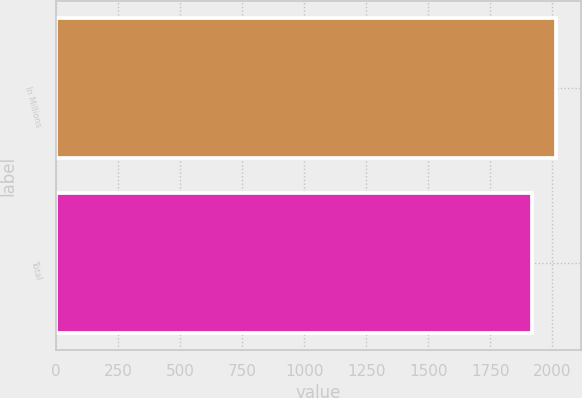Convert chart. <chart><loc_0><loc_0><loc_500><loc_500><bar_chart><fcel>In Millions<fcel>Total<nl><fcel>2014<fcel>1918.8<nl></chart> 